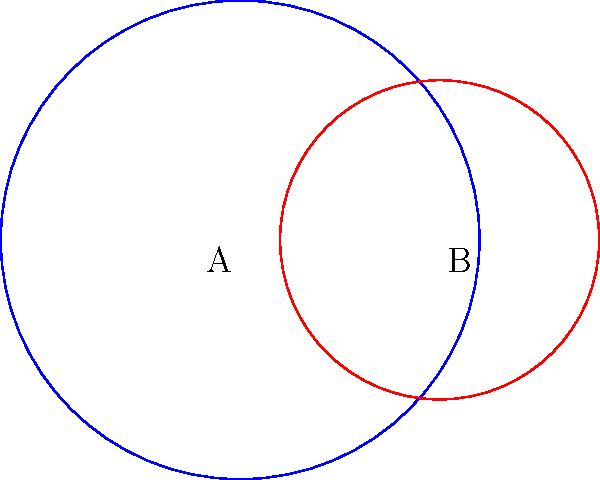In your latest mixed media artwork, you're simulating layered mineral deposits using overlapping circles. Circle A represents a larger deposit with radius 1.2 cm, while circle B represents a smaller deposit with radius 0.8 cm. The centers of these circles are 1 cm apart. Calculate the total surface area of the combined mineral deposits, rounded to two decimal places. To find the total surface area of the combined mineral deposits, we need to:

1) Calculate the areas of both circles
2) Find the area of overlap
3) Subtract the overlap from the sum of the individual areas

Step 1: Calculate the areas of both circles
Area of circle A: $A_1 = \pi r_1^2 = \pi (1.2)^2 = 1.44\pi$ cm²
Area of circle B: $A_2 = \pi r_2^2 = \pi (0.8)^2 = 0.64\pi$ cm²

Step 2: Find the area of overlap
To find the overlap, we use the formula for the area of intersection of two circles:

$A_{overlap} = r_1^2 \arccos(\frac{d^2 + r_1^2 - r_2^2}{2dr_1}) + r_2^2 \arccos(\frac{d^2 + r_2^2 - r_1^2}{2dr_2}) - \frac{1}{2}\sqrt{(-d+r_1+r_2)(d+r_1-r_2)(d-r_1+r_2)(d+r_1+r_2)}$

Where $d$ is the distance between the centers (1 cm)

Plugging in the values:
$A_{overlap} = (1.2)^2 \arccos(\frac{1^2 + 1.2^2 - 0.8^2}{2(1)(1.2)}) + (0.8)^2 \arccos(\frac{1^2 + 0.8^2 - 1.2^2}{2(1)(0.8)}) - \frac{1}{2}\sqrt{(-1+1.2+0.8)(1+1.2-0.8)(1-1.2+0.8)(1+1.2+0.8)}$

$A_{overlap} \approx 0.7238$ cm²

Step 3: Calculate the total area
Total Area = Area of circle A + Area of circle B - Area of overlap
$A_{total} = 1.44\pi + 0.64\pi - 0.7238$
$A_{total} \approx 6.5162$ cm²

Rounding to two decimal places: 6.52 cm²
Answer: 6.52 cm² 